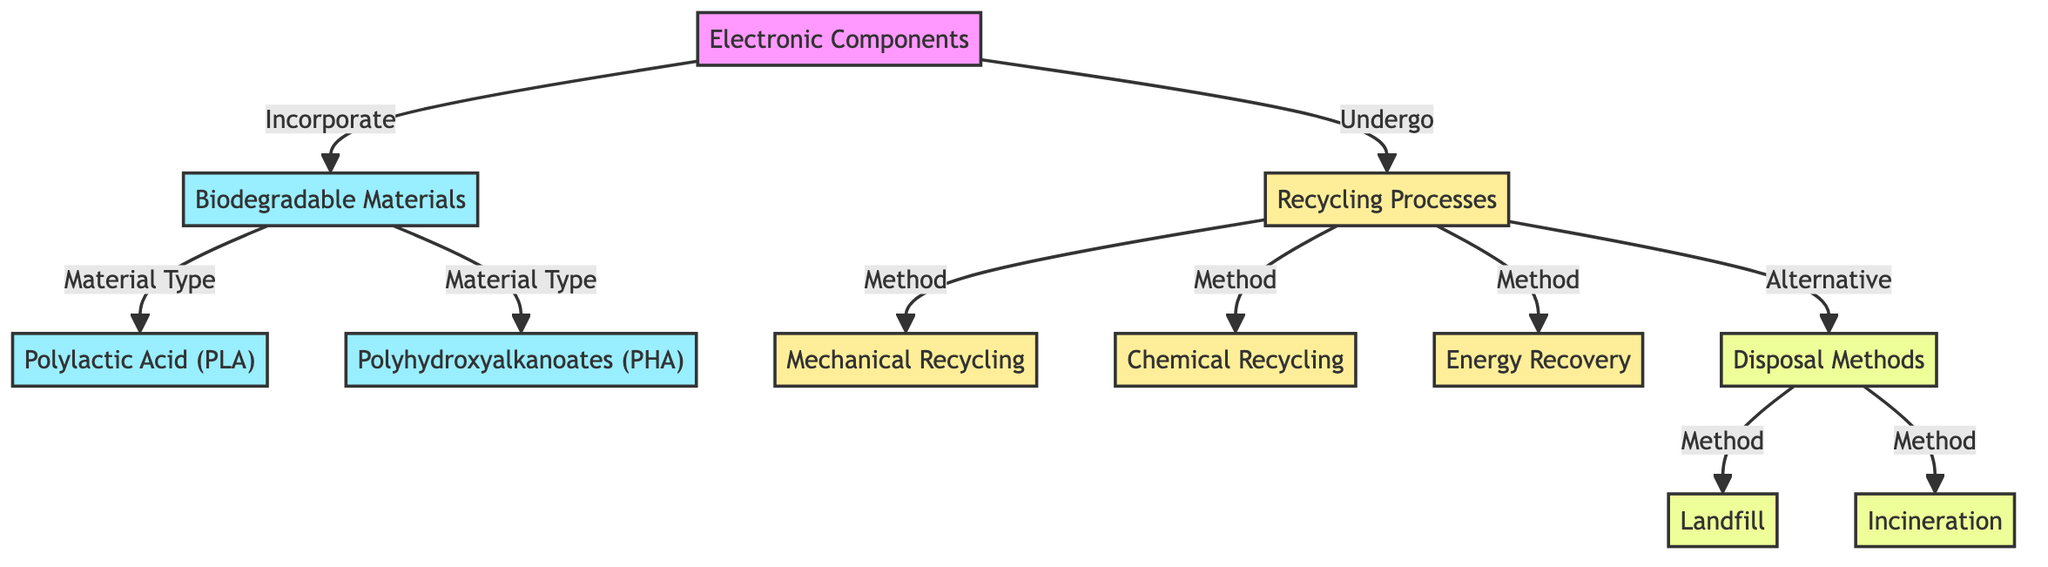What are the two types of biodegradable materials listed? The diagram shows two types of biodegradable materials specifically linked to electronic components: Polylactic Acid (PLA) and Polyhydroxyalkanoates (PHA). These are directly derived from the biodegradable materials node.
Answer: Polylactic Acid (PLA), Polyhydroxyalkanoates (PHA) How many recycling processes are outlined in the diagram? The diagram lists three distinct recycling processes: mechanical recycling, chemical recycling, and energy recovery. These are the methods connected to the recycling processes node.
Answer: 3 What is the alternative to recycling processes mentioned? The diagram indicates that after recycling processes, there is an alternative disposal methods node. This node includes options like landfill and incineration.
Answer: Disposal Methods Which biodegradable material is specifically mentioned alongside electronic components? The diagram shows that electronic components incorporate biodegradable materials, specifically listing Polylactic Acid (PLA) and Polyhydroxyalkanoates (PHA) under biodegradable materials.
Answer: Polylactic Acid (PLA) What is the relationship between electronic components and recycling processes? The diagram indicates that electronic components undergo recycling processes, which suggests that there is a direct connection where electronic components are processed for recycling purposes.
Answer: Undergo What methods fall under the category of disposal methods? The diagram illustrates that the disposal methods branch includes landfill and incineration. These are specifically listed under the disposal methods node of the diagram.
Answer: Landfill, Incineration Which type of recycling method utilizes material physically? According to the diagram, mechanical recycling is categorized as a method under recycling processes that uses physical means to recycle materials. This method is explicitly connected to recycling processes.
Answer: Mechanical Recycling Which recycling method is related to chemical decomposition? The diagram connects chemical recycling as a method that involves the chemical decomposition of materials, making it distinct from mechanical processes.
Answer: Chemical Recycling 